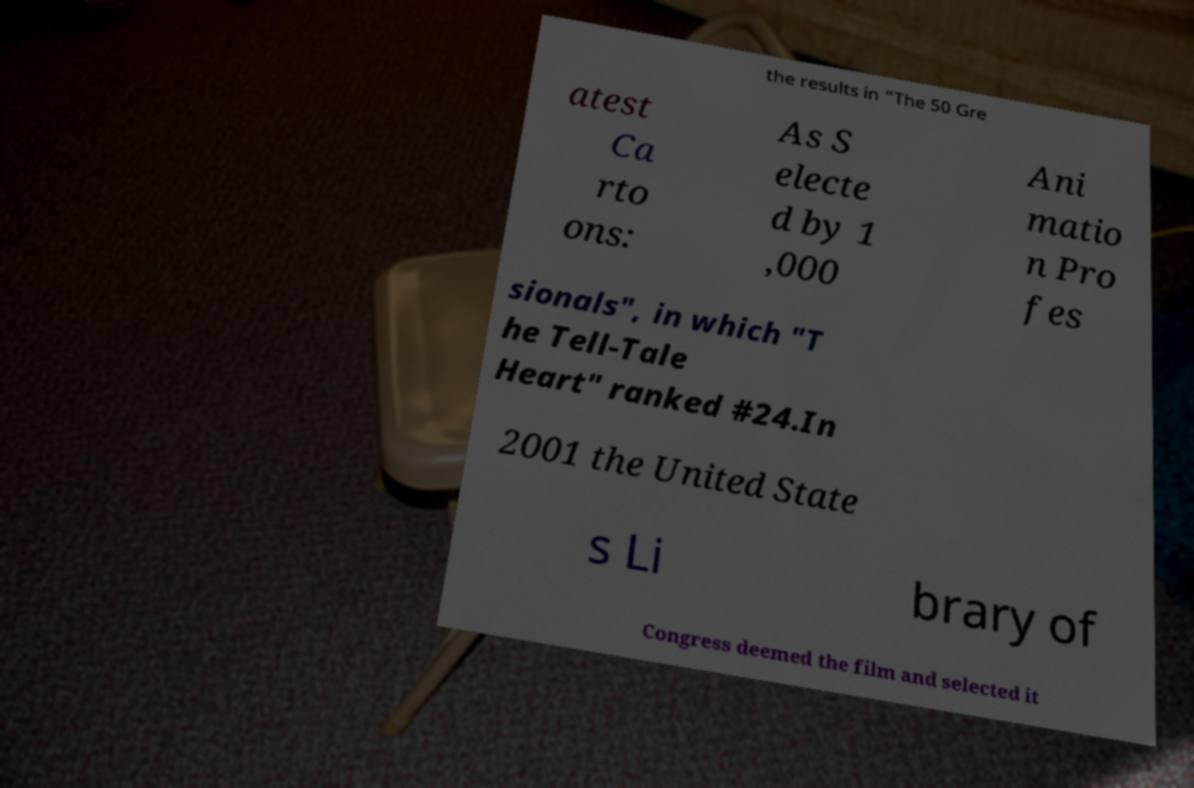For documentation purposes, I need the text within this image transcribed. Could you provide that? the results in "The 50 Gre atest Ca rto ons: As S electe d by 1 ,000 Ani matio n Pro fes sionals", in which "T he Tell-Tale Heart" ranked #24.In 2001 the United State s Li brary of Congress deemed the film and selected it 